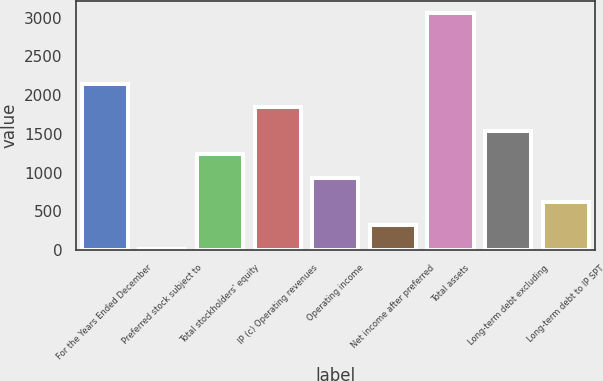<chart> <loc_0><loc_0><loc_500><loc_500><bar_chart><fcel>For the Years Ended December<fcel>Preferred stock subject to<fcel>Total stockholders' equity<fcel>IP (c) Operating revenues<fcel>Operating income<fcel>Net income after preferred<fcel>Total assets<fcel>Long-term debt excluding<fcel>Long-term debt to IP SPT<nl><fcel>2144.9<fcel>19<fcel>1233.8<fcel>1841.2<fcel>930.1<fcel>322.7<fcel>3056<fcel>1537.5<fcel>626.4<nl></chart> 